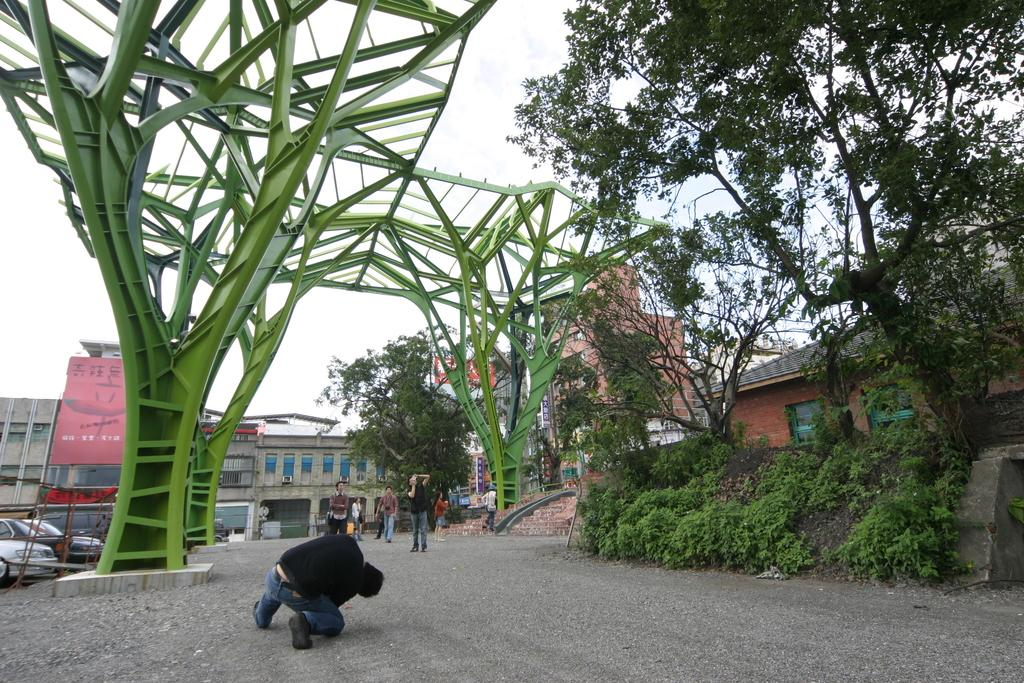Who or what can be seen in the image? There are people in the image. What type of vegetation is on the right side of the image? There are trees on the right side of the image. What architectural feature is on the left side of the image? There is an arch on the left side of the image. What structures are visible in the background of the image? There are buildings in the background of the image. What type of vehicles are visible in the background of the image? There are cars in the background of the image. What is visible at the top of the image? The sky is visible at the top of the image. What type of wire is being used by the group to reach the limit in the image? There is no wire or group present in the image, and no limit is being reached. 